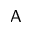Convert formula to latex. <formula><loc_0><loc_0><loc_500><loc_500>A</formula> 